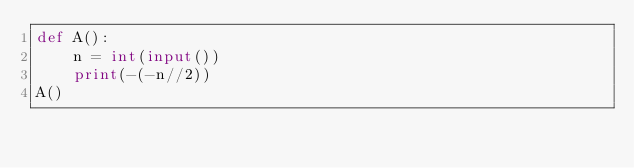Convert code to text. <code><loc_0><loc_0><loc_500><loc_500><_Python_>def A():
    n = int(input())
    print(-(-n//2))
A()</code> 